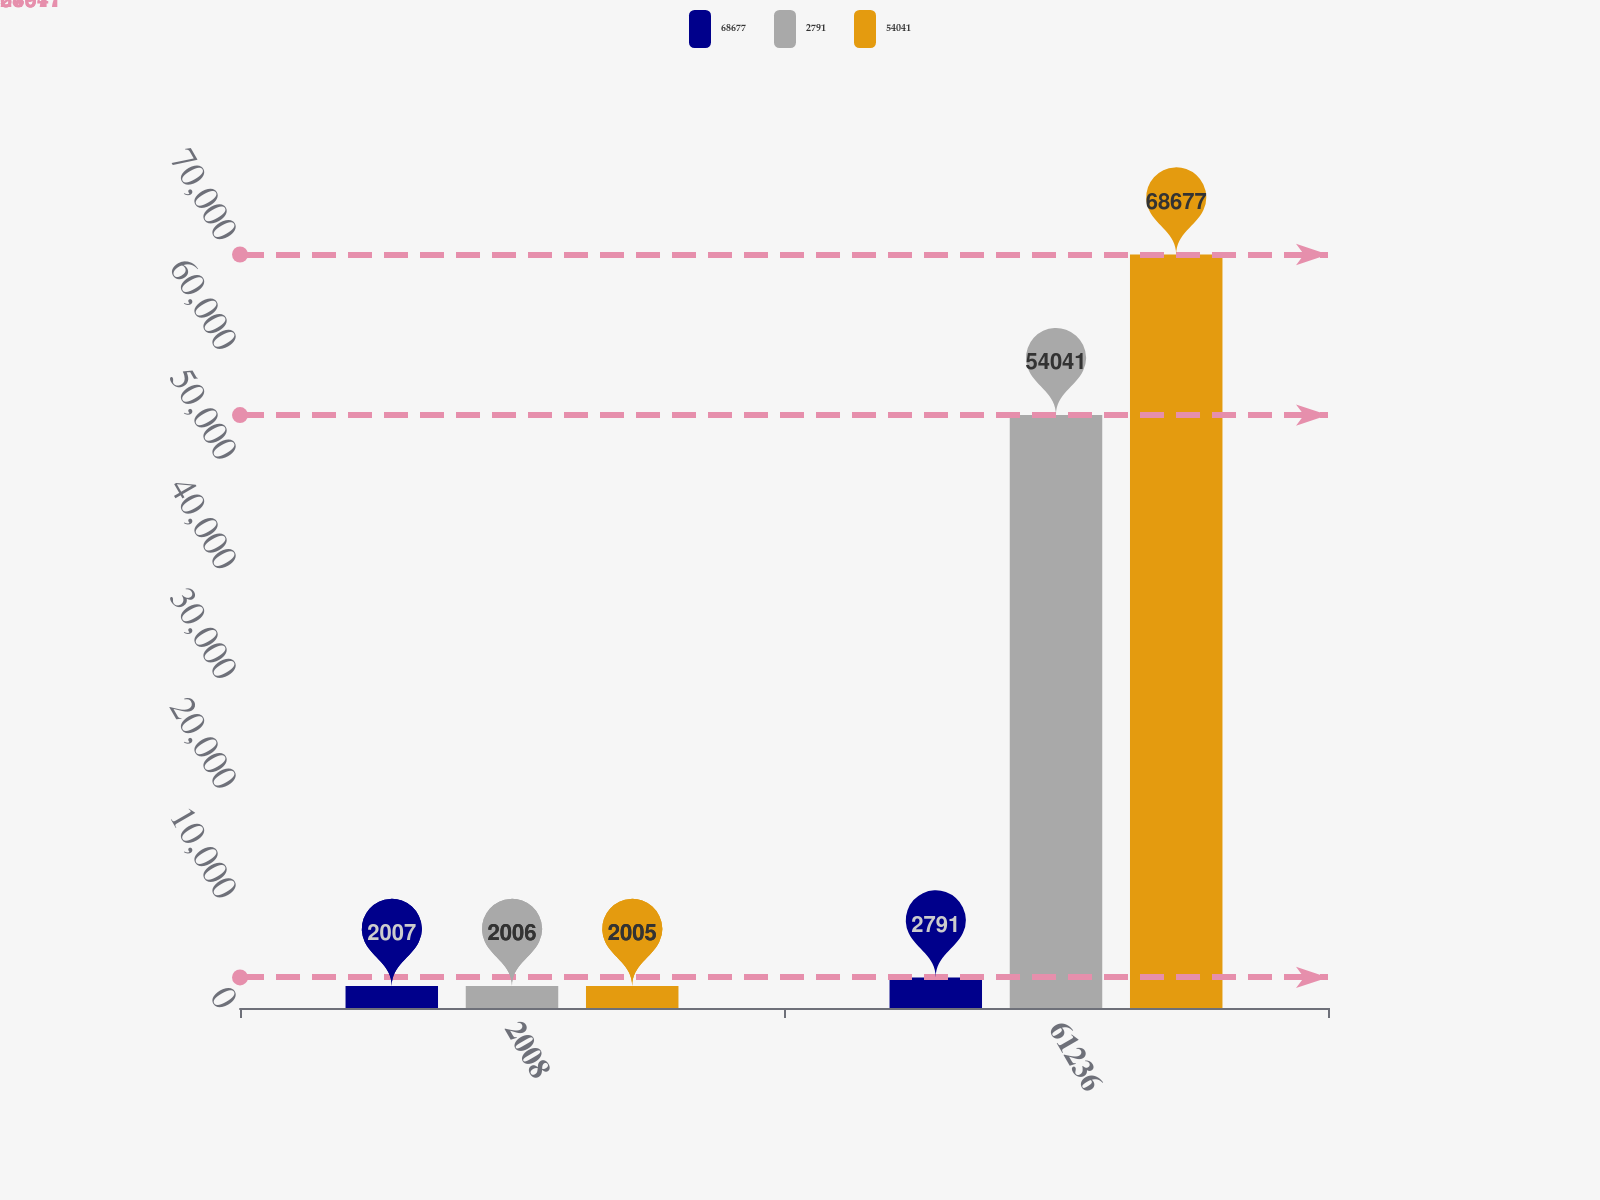Convert chart to OTSL. <chart><loc_0><loc_0><loc_500><loc_500><stacked_bar_chart><ecel><fcel>2008<fcel>61236<nl><fcel>68677<fcel>2007<fcel>2791<nl><fcel>2791<fcel>2006<fcel>54041<nl><fcel>54041<fcel>2005<fcel>68677<nl></chart> 